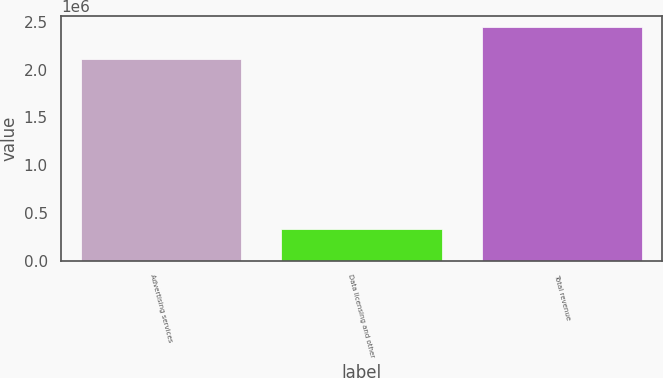<chart> <loc_0><loc_0><loc_500><loc_500><bar_chart><fcel>Advertising services<fcel>Data licensing and other<fcel>Total revenue<nl><fcel>2.10999e+06<fcel>333312<fcel>2.4433e+06<nl></chart> 